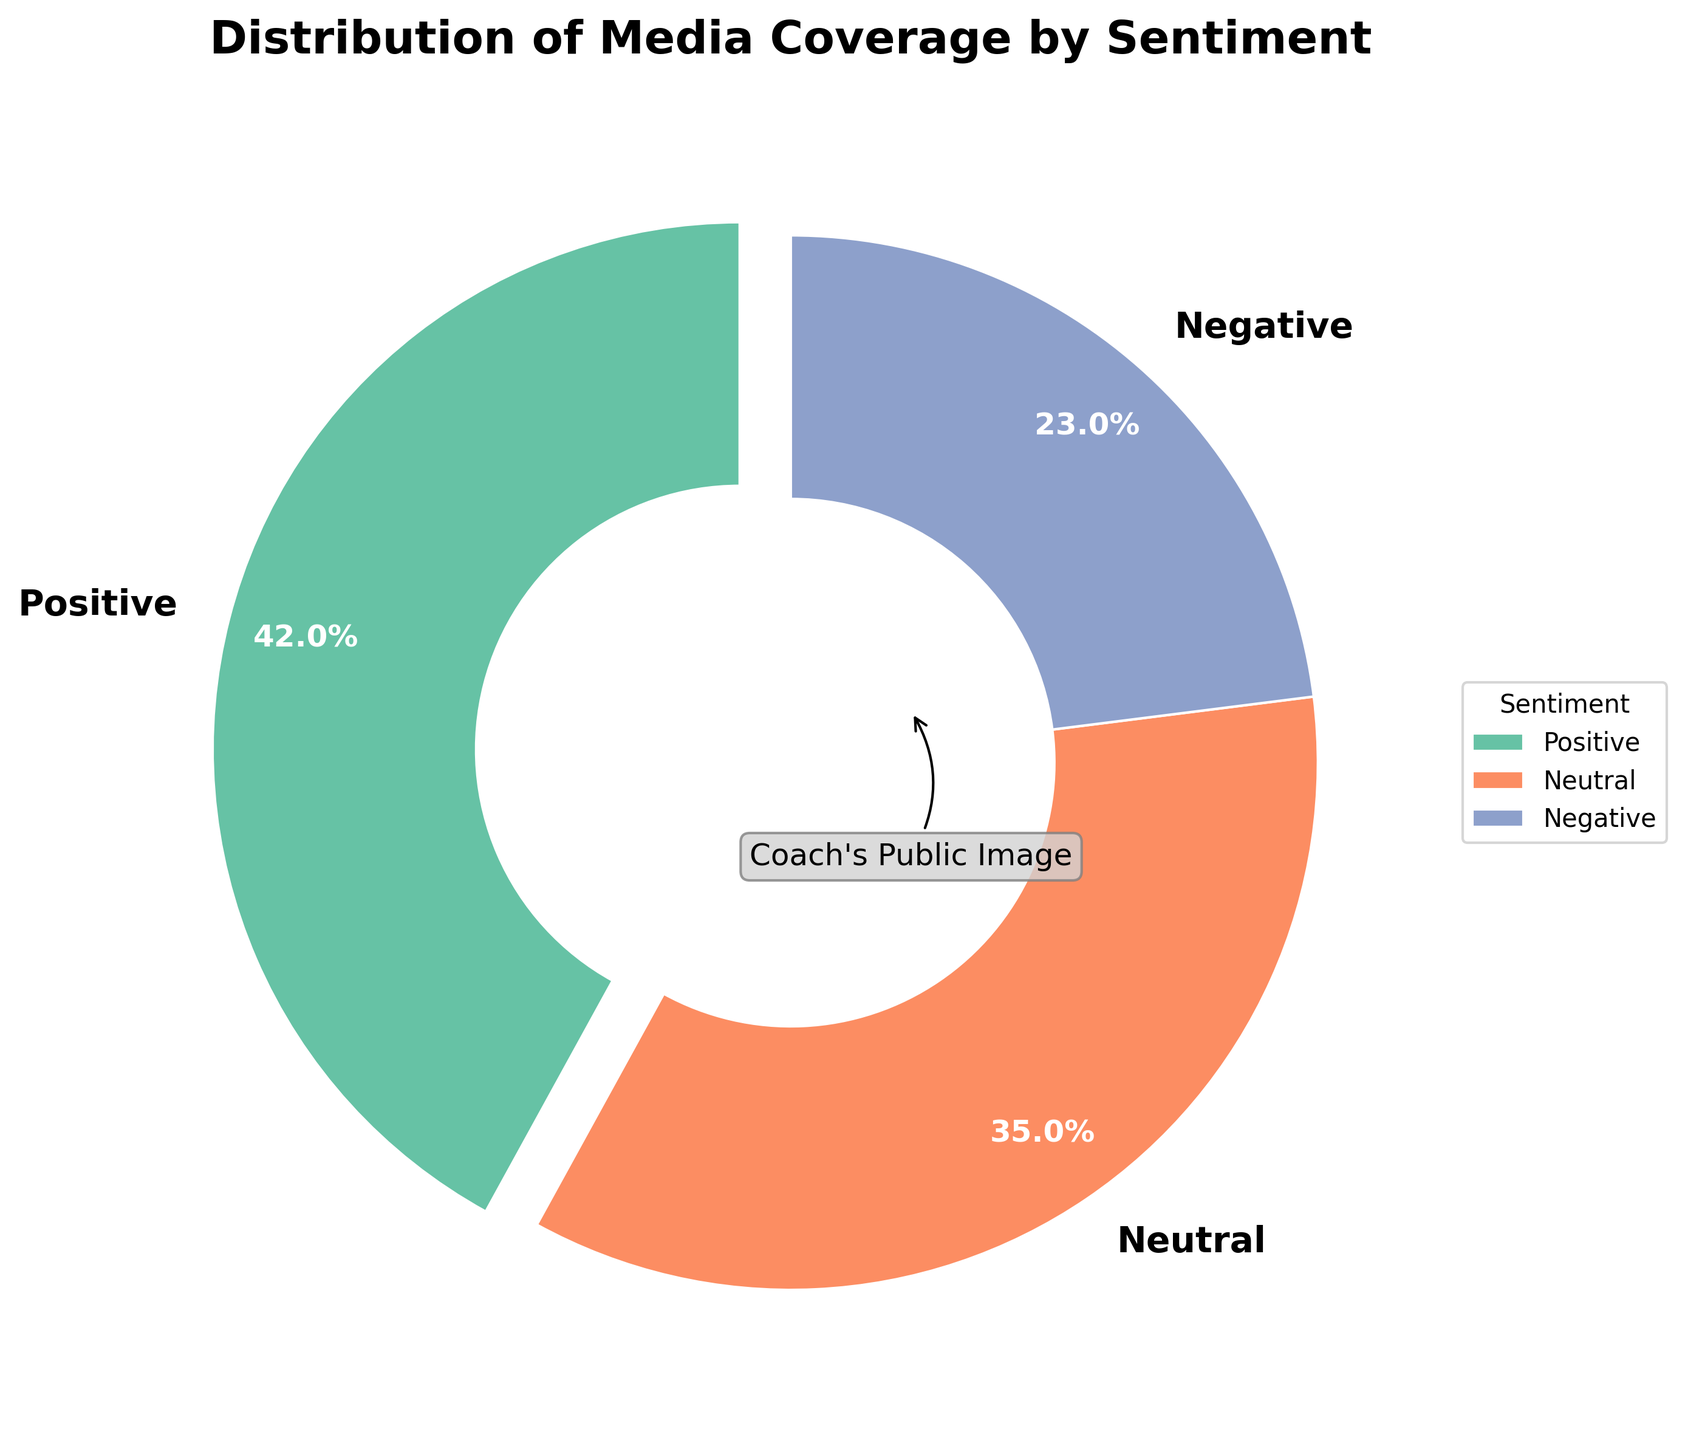What percentage of the media coverage is negative? Look at the segment labeled "Negative" on the pie chart, which represents the portion of negative media coverage. It is indicated by the percentage inside the negative segment.
Answer: 23% How much larger is the positive media coverage compared to the negative media coverage? Find the percentage of positive media coverage from the positive segment and the percentage of negative media coverage from the negative segment on the pie chart. Then subtract the negative percentage from the positive percentage. 42% - 23% = 19%.
Answer: 19% Which sentiment has the largest percentage of media coverage? Identify the segment of the pie chart that has the largest area. It is the segment labeled "Positive".
Answer: Positive What is the combined percentage of neutral and negative media coverage? Locate the percentages for the neutral and negative segments on the pie chart. Add these two percentages together. 35% + 23% = 58%.
Answer: 58% Which sentiment has the smallest percentage of media coverage? Identify the segment of the pie chart that has the smallest area. It is the segment labeled "Negative".
Answer: Negative How does the percentage of positive media coverage compare to the combined percentage of neutral and negative media coverage? Compare the percentage of positive media coverage with the combined percentage of neutral and negative media coverage. Positive media coverage is 42%, while the combined neutral and negative coverage is 58%. Hence, 42% is less than 58%.
Answer: Less than What color is used to represent the neutral sentiment in the pie chart? Look at the segment labeled "Neutral" on the pie chart and note the color used to fill this segment.
Answer: Orange What percentage of media coverage represents sentiments other than positive? Find the total percentage of the neutral and negative segments on the pie chart. Add these two percentages: 35% (Neutral) + 23% (Negative) = 58%.
Answer: 58% What is the central annotation on the pie chart? Identify the text annotation placed at the center of the pie chart. It is explicitly written there.
Answer: Coach's Public Image 